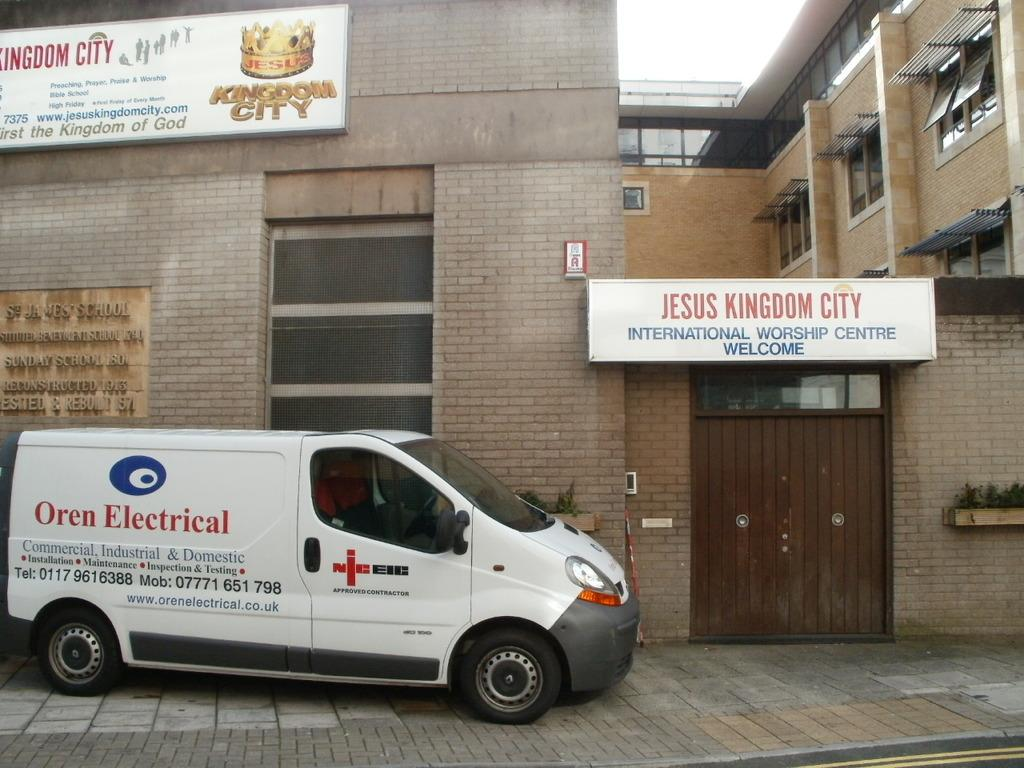Provide a one-sentence caption for the provided image. A car for an electrical company is on the outside of a church. 